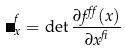Convert formula to latex. <formula><loc_0><loc_0><loc_500><loc_500>\Delta ^ { f } _ { x } = \det \frac { \partial f ^ { \alpha } ( x ) } { \partial x ^ { \beta } }</formula> 